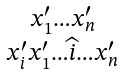Convert formula to latex. <formula><loc_0><loc_0><loc_500><loc_500>\begin{smallmatrix} x _ { 1 } ^ { \prime } \dots x _ { n } ^ { \prime } \\ x _ { i } ^ { \prime } x _ { 1 } ^ { \prime } \dots \widehat { i } \dots x _ { n } ^ { \prime } \end{smallmatrix}</formula> 